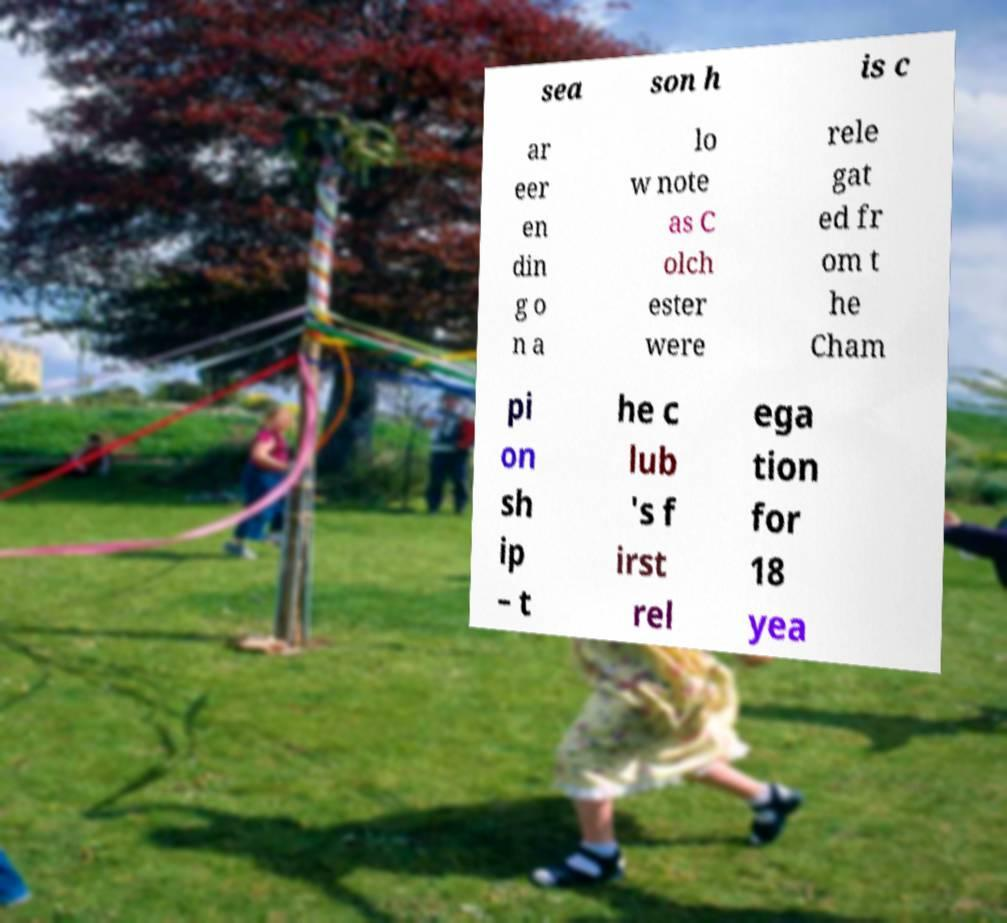There's text embedded in this image that I need extracted. Can you transcribe it verbatim? sea son h is c ar eer en din g o n a lo w note as C olch ester were rele gat ed fr om t he Cham pi on sh ip – t he c lub 's f irst rel ega tion for 18 yea 